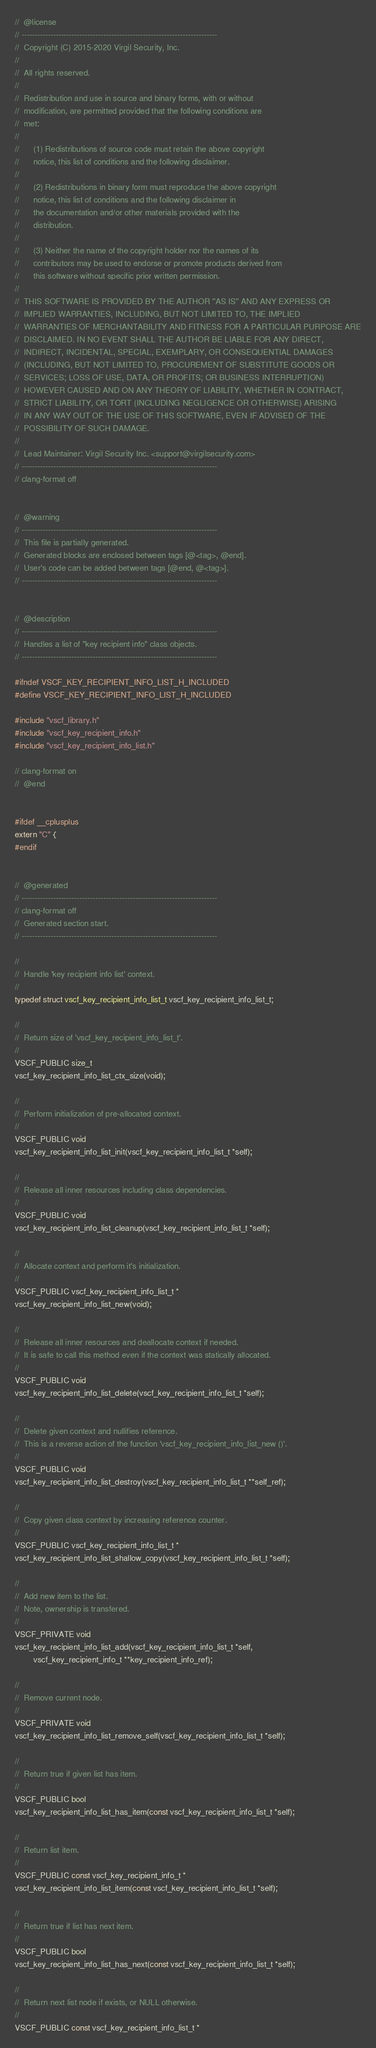Convert code to text. <code><loc_0><loc_0><loc_500><loc_500><_C_>//  @license
// --------------------------------------------------------------------------
//  Copyright (C) 2015-2020 Virgil Security, Inc.
//
//  All rights reserved.
//
//  Redistribution and use in source and binary forms, with or without
//  modification, are permitted provided that the following conditions are
//  met:
//
//      (1) Redistributions of source code must retain the above copyright
//      notice, this list of conditions and the following disclaimer.
//
//      (2) Redistributions in binary form must reproduce the above copyright
//      notice, this list of conditions and the following disclaimer in
//      the documentation and/or other materials provided with the
//      distribution.
//
//      (3) Neither the name of the copyright holder nor the names of its
//      contributors may be used to endorse or promote products derived from
//      this software without specific prior written permission.
//
//  THIS SOFTWARE IS PROVIDED BY THE AUTHOR ''AS IS'' AND ANY EXPRESS OR
//  IMPLIED WARRANTIES, INCLUDING, BUT NOT LIMITED TO, THE IMPLIED
//  WARRANTIES OF MERCHANTABILITY AND FITNESS FOR A PARTICULAR PURPOSE ARE
//  DISCLAIMED. IN NO EVENT SHALL THE AUTHOR BE LIABLE FOR ANY DIRECT,
//  INDIRECT, INCIDENTAL, SPECIAL, EXEMPLARY, OR CONSEQUENTIAL DAMAGES
//  (INCLUDING, BUT NOT LIMITED TO, PROCUREMENT OF SUBSTITUTE GOODS OR
//  SERVICES; LOSS OF USE, DATA, OR PROFITS; OR BUSINESS INTERRUPTION)
//  HOWEVER CAUSED AND ON ANY THEORY OF LIABILITY, WHETHER IN CONTRACT,
//  STRICT LIABILITY, OR TORT (INCLUDING NEGLIGENCE OR OTHERWISE) ARISING
//  IN ANY WAY OUT OF THE USE OF THIS SOFTWARE, EVEN IF ADVISED OF THE
//  POSSIBILITY OF SUCH DAMAGE.
//
//  Lead Maintainer: Virgil Security Inc. <support@virgilsecurity.com>
// --------------------------------------------------------------------------
// clang-format off


//  @warning
// --------------------------------------------------------------------------
//  This file is partially generated.
//  Generated blocks are enclosed between tags [@<tag>, @end].
//  User's code can be added between tags [@end, @<tag>].
// --------------------------------------------------------------------------


//  @description
// --------------------------------------------------------------------------
//  Handles a list of "key recipient info" class objects.
// --------------------------------------------------------------------------

#ifndef VSCF_KEY_RECIPIENT_INFO_LIST_H_INCLUDED
#define VSCF_KEY_RECIPIENT_INFO_LIST_H_INCLUDED

#include "vscf_library.h"
#include "vscf_key_recipient_info.h"
#include "vscf_key_recipient_info_list.h"

// clang-format on
//  @end


#ifdef __cplusplus
extern "C" {
#endif


//  @generated
// --------------------------------------------------------------------------
// clang-format off
//  Generated section start.
// --------------------------------------------------------------------------

//
//  Handle 'key recipient info list' context.
//
typedef struct vscf_key_recipient_info_list_t vscf_key_recipient_info_list_t;

//
//  Return size of 'vscf_key_recipient_info_list_t'.
//
VSCF_PUBLIC size_t
vscf_key_recipient_info_list_ctx_size(void);

//
//  Perform initialization of pre-allocated context.
//
VSCF_PUBLIC void
vscf_key_recipient_info_list_init(vscf_key_recipient_info_list_t *self);

//
//  Release all inner resources including class dependencies.
//
VSCF_PUBLIC void
vscf_key_recipient_info_list_cleanup(vscf_key_recipient_info_list_t *self);

//
//  Allocate context and perform it's initialization.
//
VSCF_PUBLIC vscf_key_recipient_info_list_t *
vscf_key_recipient_info_list_new(void);

//
//  Release all inner resources and deallocate context if needed.
//  It is safe to call this method even if the context was statically allocated.
//
VSCF_PUBLIC void
vscf_key_recipient_info_list_delete(vscf_key_recipient_info_list_t *self);

//
//  Delete given context and nullifies reference.
//  This is a reverse action of the function 'vscf_key_recipient_info_list_new ()'.
//
VSCF_PUBLIC void
vscf_key_recipient_info_list_destroy(vscf_key_recipient_info_list_t **self_ref);

//
//  Copy given class context by increasing reference counter.
//
VSCF_PUBLIC vscf_key_recipient_info_list_t *
vscf_key_recipient_info_list_shallow_copy(vscf_key_recipient_info_list_t *self);

//
//  Add new item to the list.
//  Note, ownership is transfered.
//
VSCF_PRIVATE void
vscf_key_recipient_info_list_add(vscf_key_recipient_info_list_t *self,
        vscf_key_recipient_info_t **key_recipient_info_ref);

//
//  Remove current node.
//
VSCF_PRIVATE void
vscf_key_recipient_info_list_remove_self(vscf_key_recipient_info_list_t *self);

//
//  Return true if given list has item.
//
VSCF_PUBLIC bool
vscf_key_recipient_info_list_has_item(const vscf_key_recipient_info_list_t *self);

//
//  Return list item.
//
VSCF_PUBLIC const vscf_key_recipient_info_t *
vscf_key_recipient_info_list_item(const vscf_key_recipient_info_list_t *self);

//
//  Return true if list has next item.
//
VSCF_PUBLIC bool
vscf_key_recipient_info_list_has_next(const vscf_key_recipient_info_list_t *self);

//
//  Return next list node if exists, or NULL otherwise.
//
VSCF_PUBLIC const vscf_key_recipient_info_list_t *</code> 